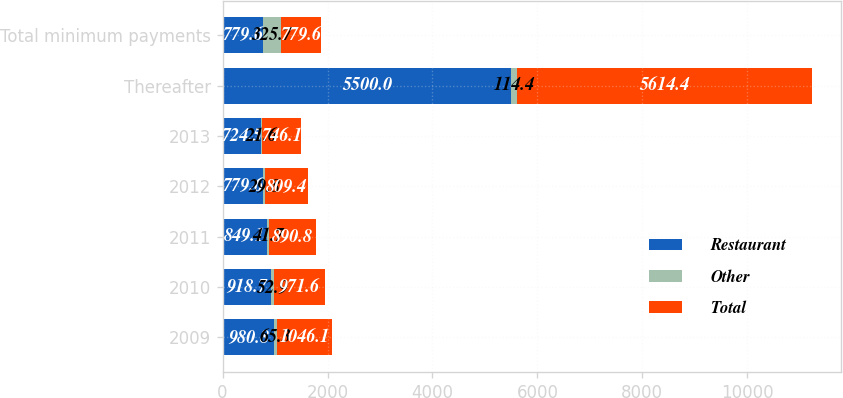<chart> <loc_0><loc_0><loc_500><loc_500><stacked_bar_chart><ecel><fcel>2009<fcel>2010<fcel>2011<fcel>2012<fcel>2013<fcel>Thereafter<fcel>Total minimum payments<nl><fcel>Restaurant<fcel>980.8<fcel>918.7<fcel>849.1<fcel>779.6<fcel>724.5<fcel>5500<fcel>779.6<nl><fcel>Other<fcel>65.3<fcel>52.9<fcel>41.7<fcel>29.8<fcel>21.6<fcel>114.4<fcel>325.7<nl><fcel>Total<fcel>1046.1<fcel>971.6<fcel>890.8<fcel>809.4<fcel>746.1<fcel>5614.4<fcel>779.6<nl></chart> 